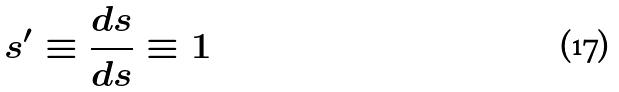<formula> <loc_0><loc_0><loc_500><loc_500>s ^ { \prime } \equiv \frac { d s } { d s } \equiv 1</formula> 